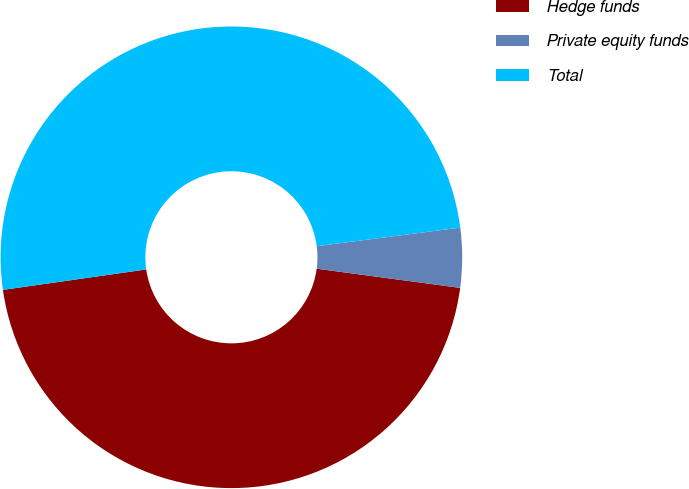Convert chart to OTSL. <chart><loc_0><loc_0><loc_500><loc_500><pie_chart><fcel>Hedge funds<fcel>Private equity funds<fcel>Total<nl><fcel>45.63%<fcel>4.17%<fcel>50.2%<nl></chart> 